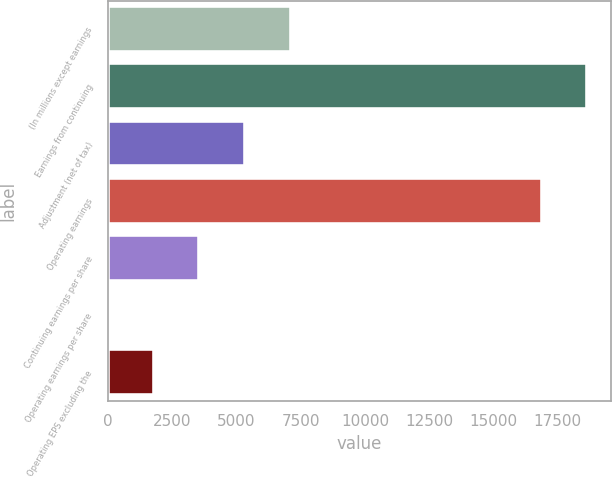<chart> <loc_0><loc_0><loc_500><loc_500><bar_chart><fcel>(In millions except earnings<fcel>Earnings from continuing<fcel>Adjustment (net of tax)<fcel>Operating earnings<fcel>Continuing earnings per share<fcel>Operating earnings per share<fcel>Operating EPS excluding the<nl><fcel>7115.38<fcel>18649.4<fcel>5336.95<fcel>16871<fcel>3558.52<fcel>1.66<fcel>1780.09<nl></chart> 